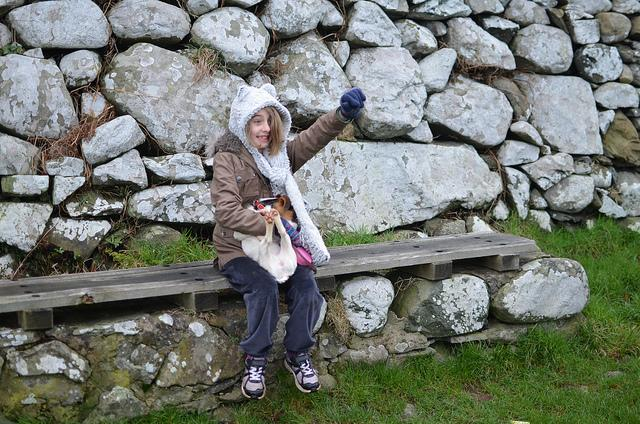What does the girl hold? dog 